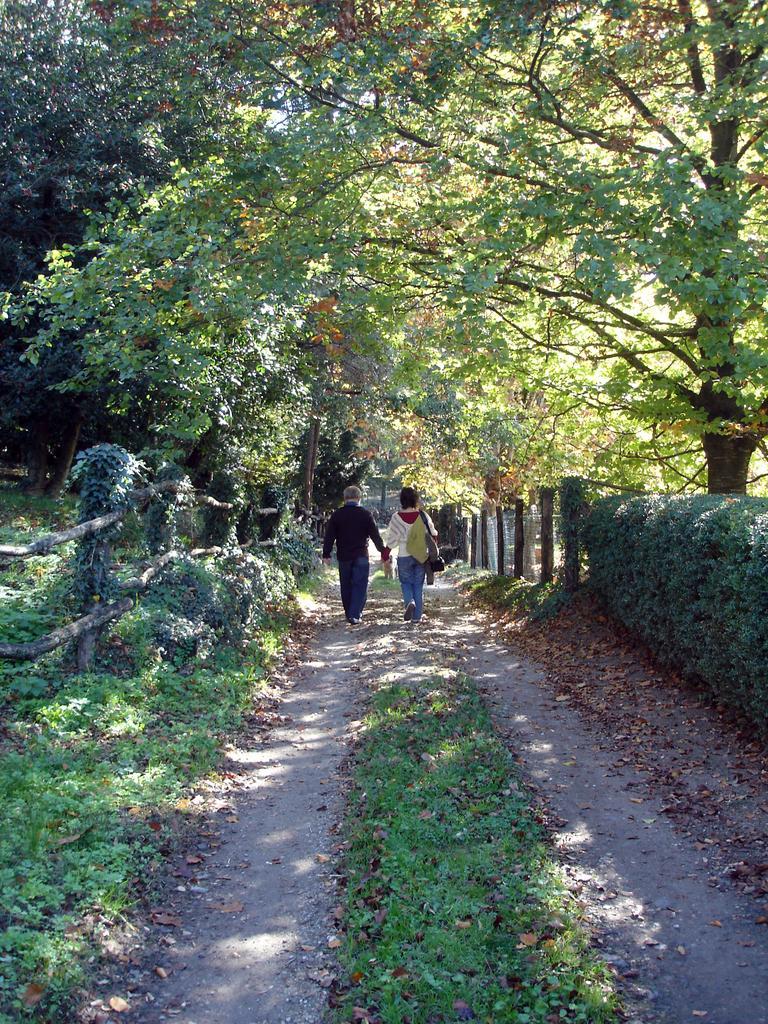In one or two sentences, can you explain what this image depicts? In the center of the image there are two people walking on the road. At the bottom of the image there is grass on the surface. On both right and left side of the image there is a wooden fence. In the background of the image there are trees. 